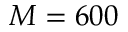Convert formula to latex. <formula><loc_0><loc_0><loc_500><loc_500>M = 6 0 0</formula> 